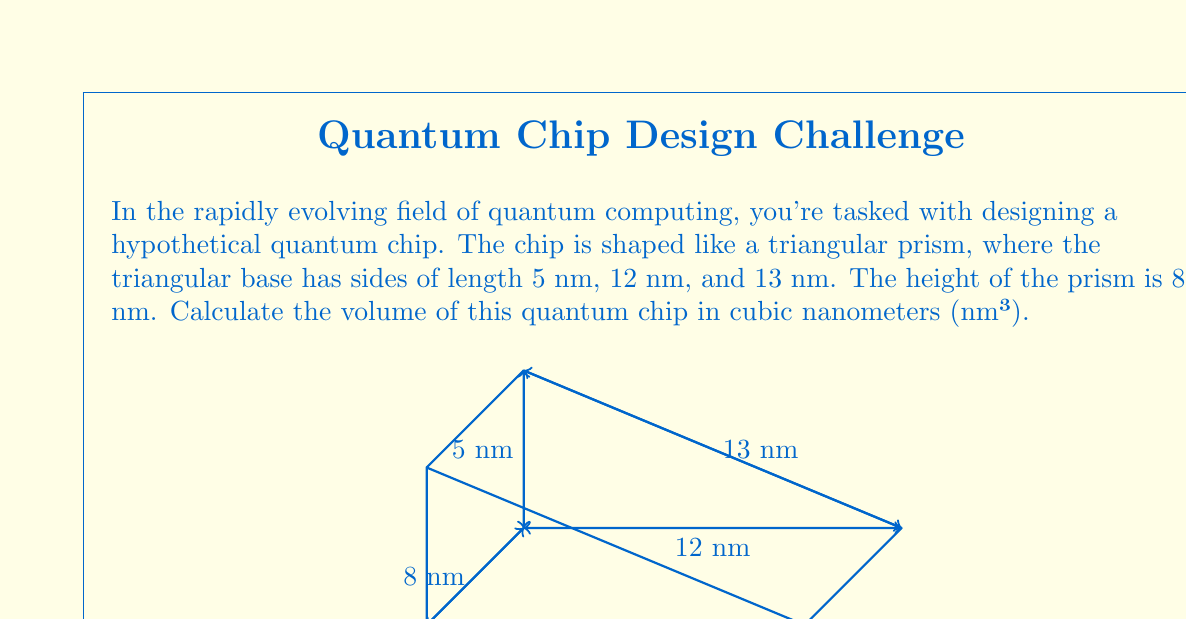Help me with this question. Let's approach this step-by-step:

1) The volume of a triangular prism is given by the formula:
   
   $$ V = A_b \cdot h $$
   
   where $A_b$ is the area of the base (triangle) and $h$ is the height of the prism.

2) To find the area of the triangular base, we can use Heron's formula:
   
   $$ A = \sqrt{s(s-a)(s-b)(s-c)} $$
   
   where $s$ is the semi-perimeter, and $a$, $b$, and $c$ are the side lengths of the triangle.

3) Calculate the semi-perimeter:
   
   $$ s = \frac{a + b + c}{2} = \frac{5 + 12 + 13}{2} = 15 \text{ nm} $$

4) Now we can apply Heron's formula:
   
   $$ A_b = \sqrt{15(15-5)(15-12)(15-13)} = \sqrt{15 \cdot 10 \cdot 3 \cdot 2} = \sqrt{900} = 30 \text{ nm}^2 $$

5) Now that we have the base area, we can calculate the volume:
   
   $$ V = A_b \cdot h = 30 \text{ nm}^2 \cdot 8 \text{ nm} = 240 \text{ nm}^3 $$

Thus, the volume of the quantum chip is 240 cubic nanometers.
Answer: 240 nm³ 